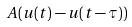Convert formula to latex. <formula><loc_0><loc_0><loc_500><loc_500>A ( u ( t ) - u ( t - \tau ) )</formula> 